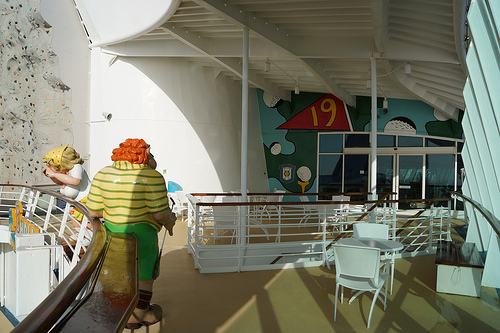<image>
Can you confirm if the roof is above the clown? Yes. The roof is positioned above the clown in the vertical space, higher up in the scene. 